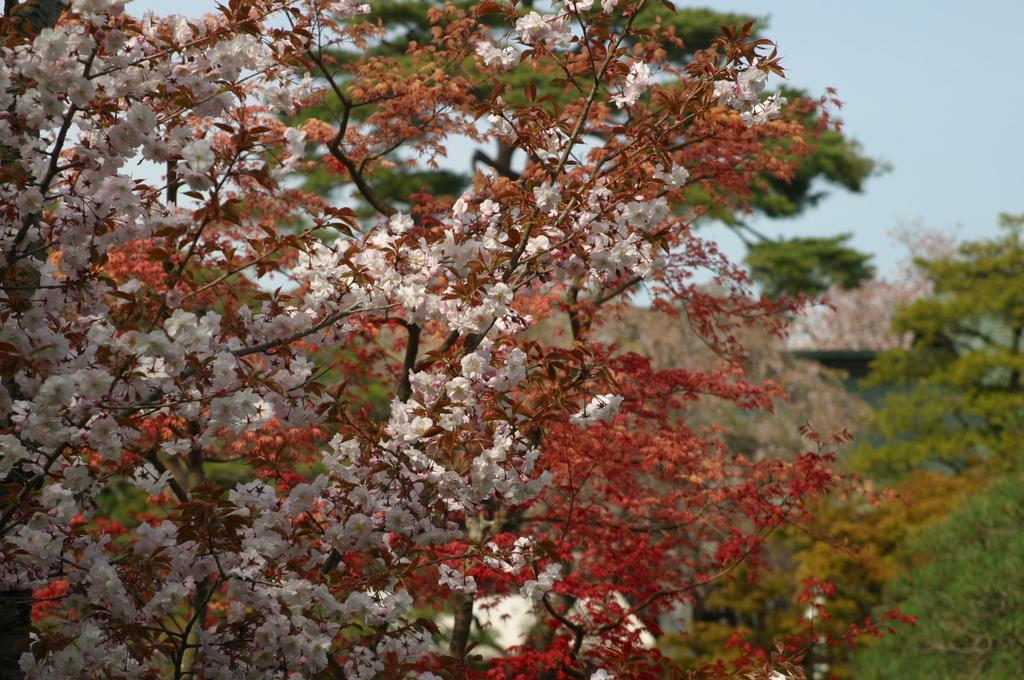How would you summarize this image in a sentence or two? In this picture I can see there are different types of trees, it has red and white color flowers and backdrop there are many other trees and the sky is clear. 